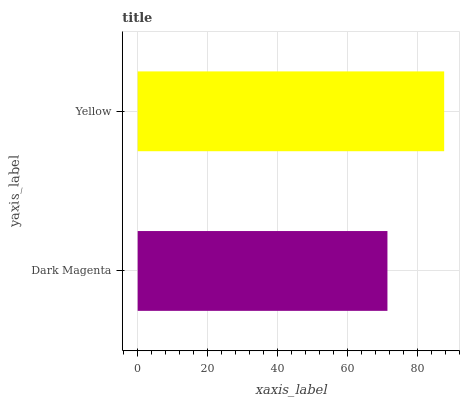Is Dark Magenta the minimum?
Answer yes or no. Yes. Is Yellow the maximum?
Answer yes or no. Yes. Is Yellow the minimum?
Answer yes or no. No. Is Yellow greater than Dark Magenta?
Answer yes or no. Yes. Is Dark Magenta less than Yellow?
Answer yes or no. Yes. Is Dark Magenta greater than Yellow?
Answer yes or no. No. Is Yellow less than Dark Magenta?
Answer yes or no. No. Is Yellow the high median?
Answer yes or no. Yes. Is Dark Magenta the low median?
Answer yes or no. Yes. Is Dark Magenta the high median?
Answer yes or no. No. Is Yellow the low median?
Answer yes or no. No. 